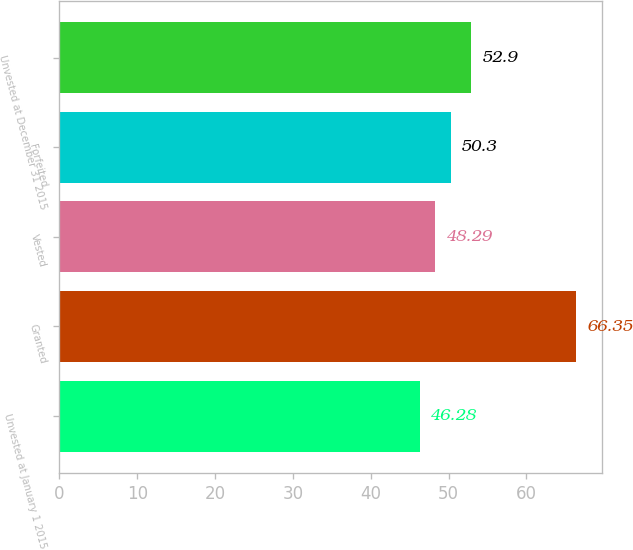Convert chart to OTSL. <chart><loc_0><loc_0><loc_500><loc_500><bar_chart><fcel>Unvested at January 1 2015<fcel>Granted<fcel>Vested<fcel>Forfeited<fcel>Unvested at December 31 2015<nl><fcel>46.28<fcel>66.35<fcel>48.29<fcel>50.3<fcel>52.9<nl></chart> 